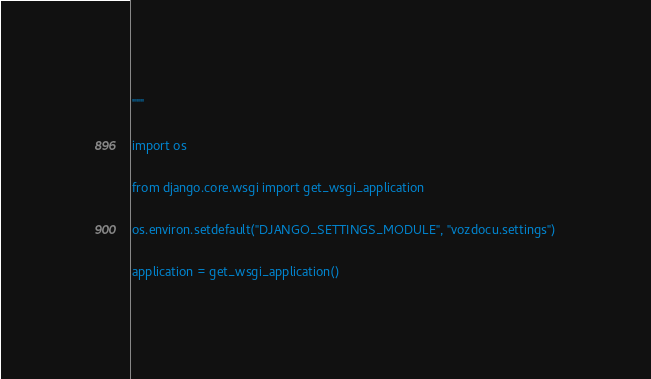<code> <loc_0><loc_0><loc_500><loc_500><_Python_>"""

import os

from django.core.wsgi import get_wsgi_application

os.environ.setdefault("DJANGO_SETTINGS_MODULE", "vozdocu.settings")

application = get_wsgi_application()
</code> 